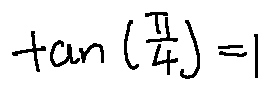<formula> <loc_0><loc_0><loc_500><loc_500>\tan ( \frac { \pi } { 4 } ) = 1</formula> 